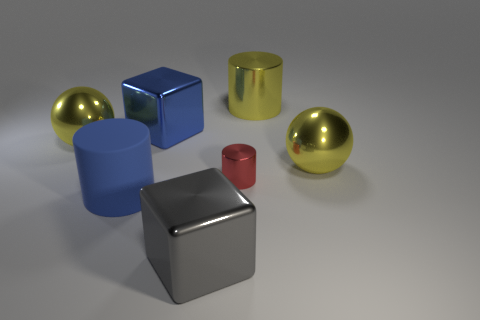Can you describe the spatial arrangement and relative sizes of the objects? Certainly. The image depicts an array of geometric objects organized randomly. Two larger spheres are placed towards the back, with one appearing slightly larger than the other. The foreground features several objects: a large blue cylinder offset to the left, a smaller red cylinder, and two cubes—one metallic and reflective, the other with a matte blue finish. The objects vary in size, creating a dynamic composition. Do the objects appear as if they could be part of a set or collection? The objects, while varying in shapes, sizes, and finishes, maintain a certain uniformity in color and simplicity of form that might suggest they are part of a designer collection or a study on shapes and textures in a three-dimensional space. 